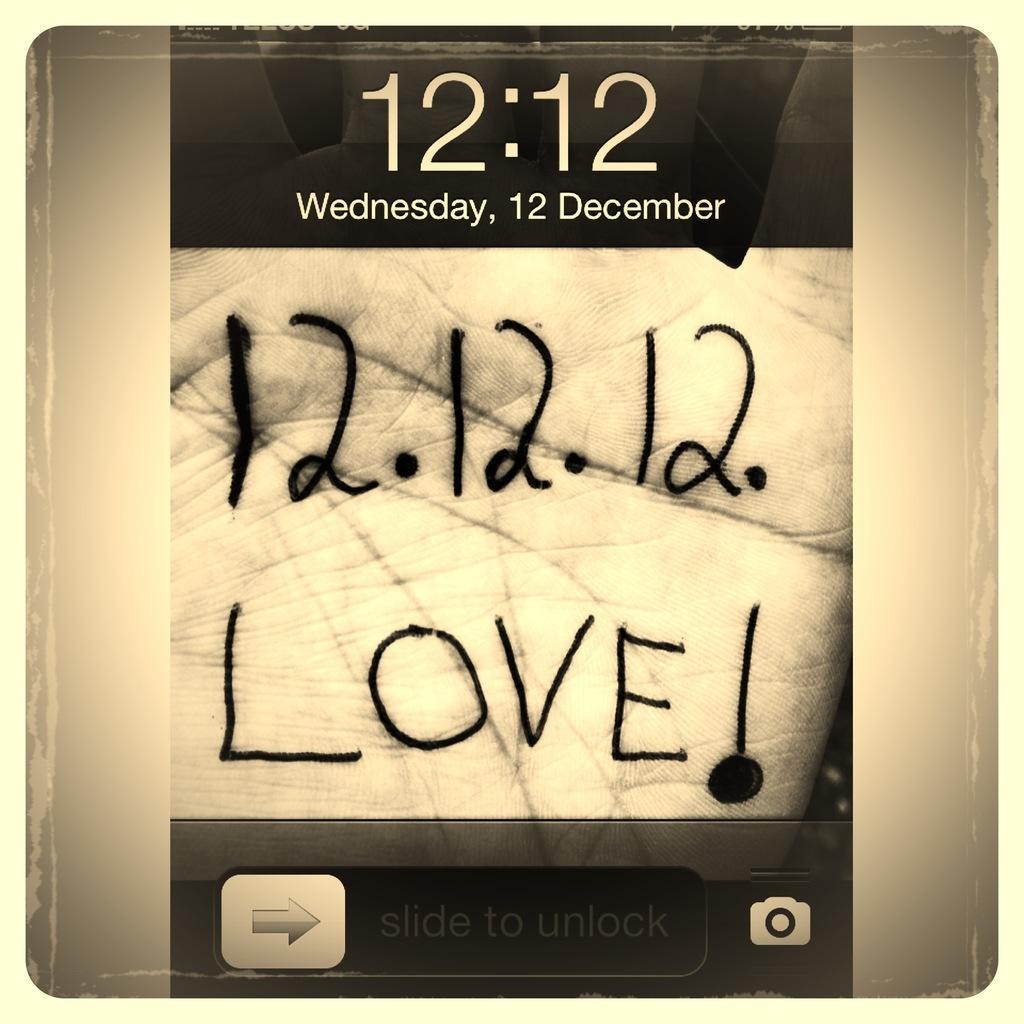Provide a one-sentence caption for the provided image. A lock screen with someone's hand having the writing 12. 12. 12. Love!. 